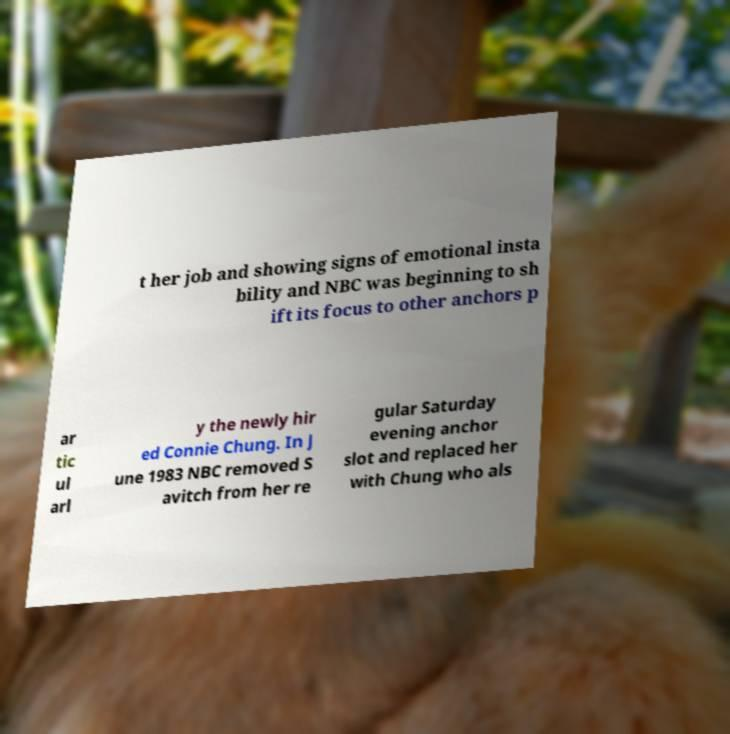What messages or text are displayed in this image? I need them in a readable, typed format. t her job and showing signs of emotional insta bility and NBC was beginning to sh ift its focus to other anchors p ar tic ul arl y the newly hir ed Connie Chung. In J une 1983 NBC removed S avitch from her re gular Saturday evening anchor slot and replaced her with Chung who als 